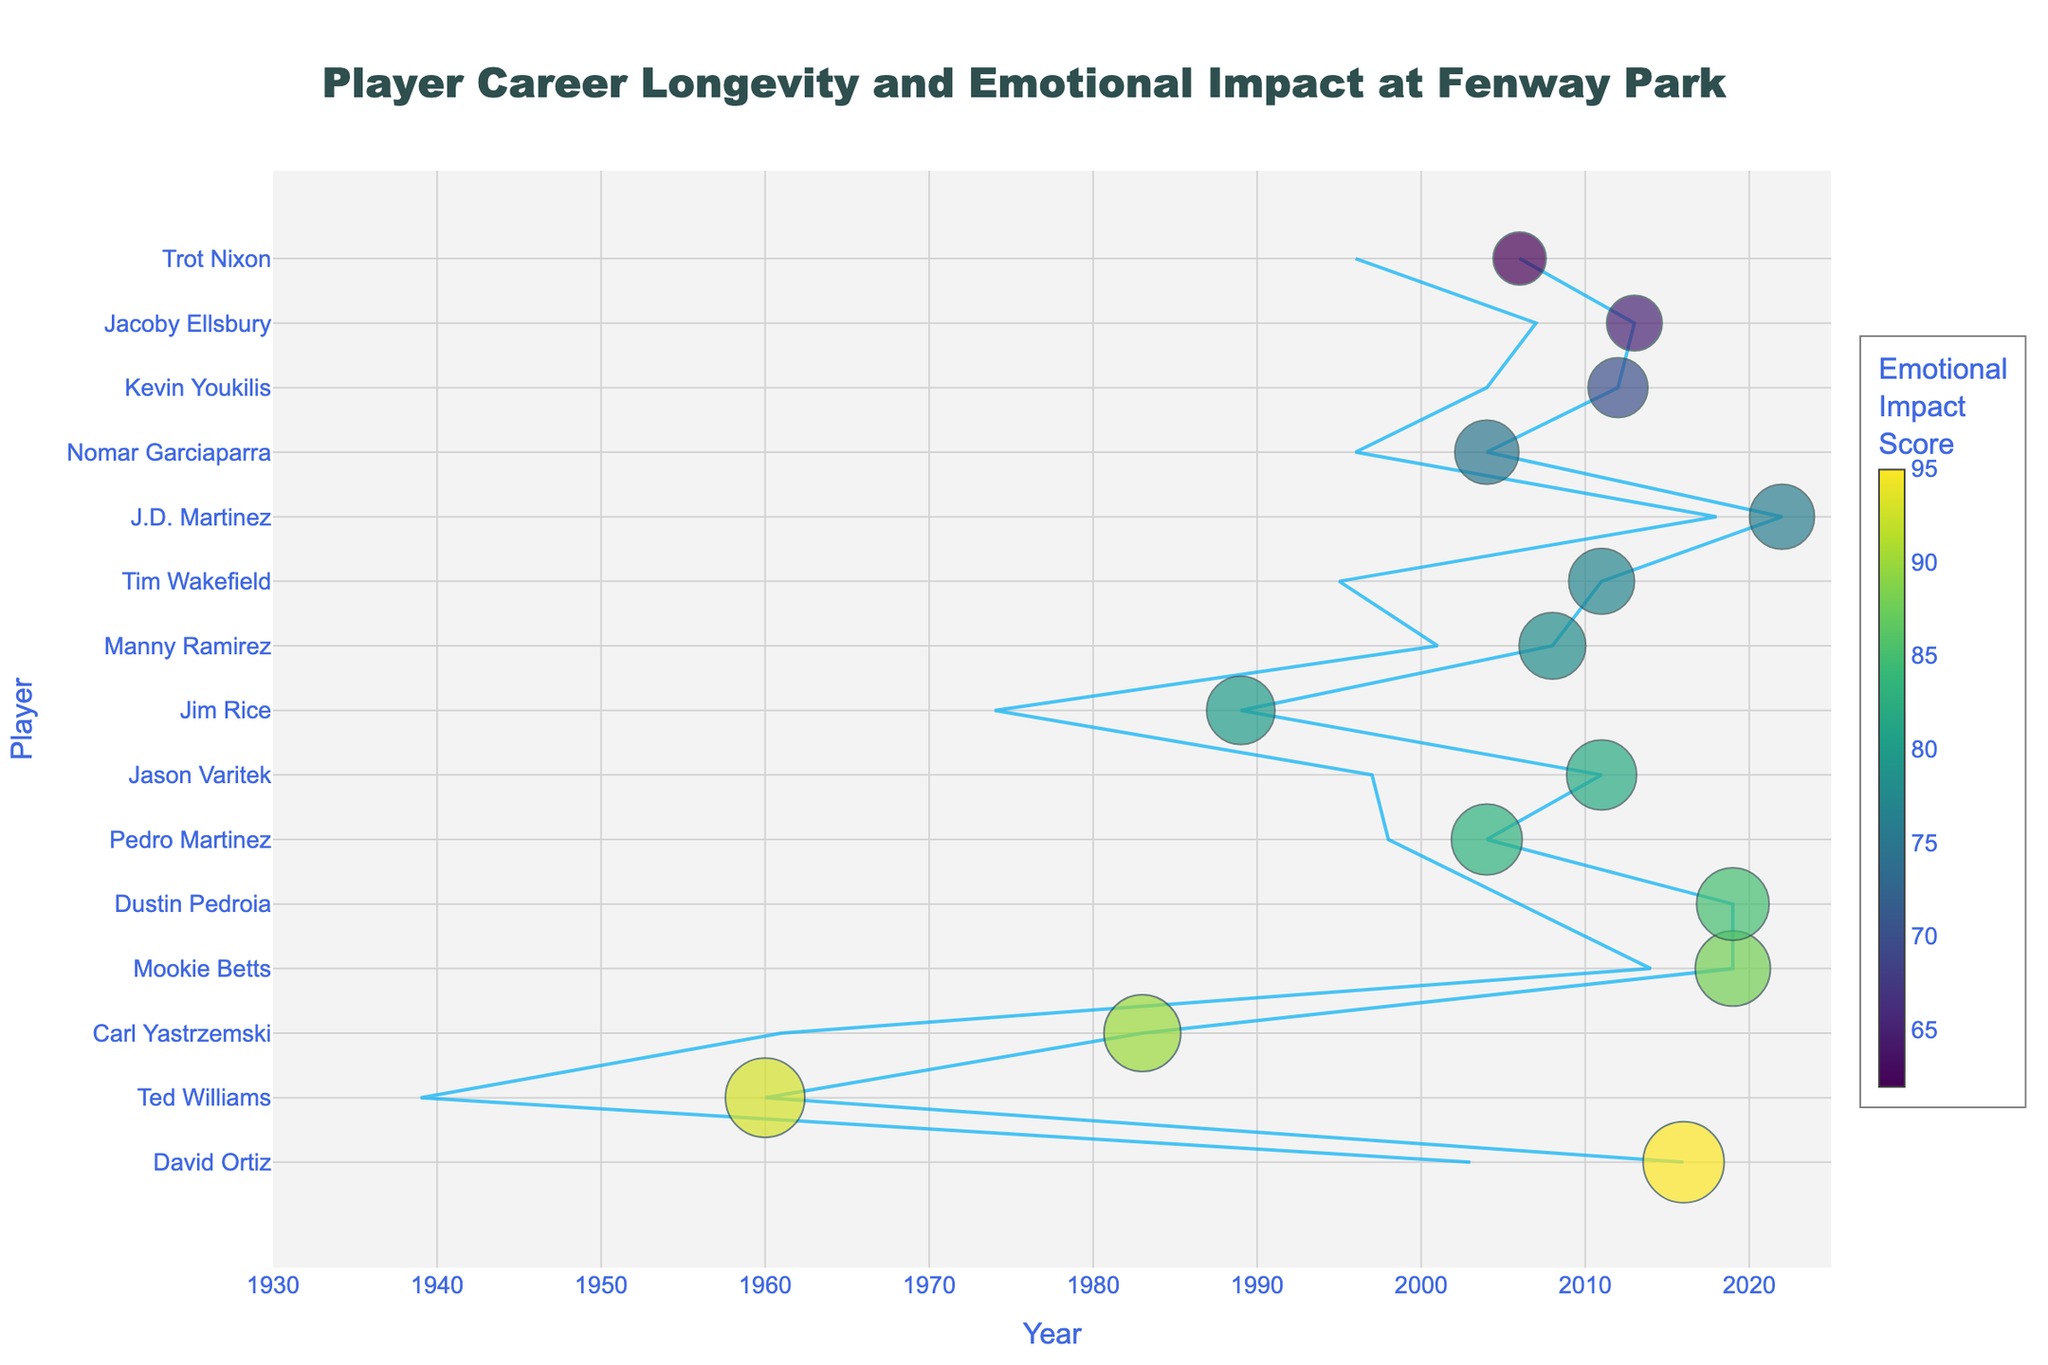What's the timeline covered in the plot? The x-axis starts from the year 1930 and extends to 2025, indicating that the timeline spans 95 years.
Answer: 1930-2025 Which player has the highest Emotional Impact Score? David Ortiz has the highest Emotional Impact Score, evident from his marker being the largest and the most intense in color. His score is 95.
Answer: David Ortiz How many players have an Emotional Impact Score of 80 or higher? To find this, count the number of players with markers that have a size and color intensity indicating scores of 80 or higher. There are 10 such players: David Ortiz, Ted Williams, Carl Yastrzemski, Mookie Betts, Dustin Pedroia, Jason Varitek, Pedro Martinez, Jim Rice, Manny Ramirez, and Tim Wakefield.
Answer: 10 Who played the longest span of years at Fenway Park? The player with the longest career span is Carl Yastrzemski, who played from 1961 to 1983, totaling 22 years.
Answer: Carl Yastrzemski Compare Ted Williams’ and Carl Yastrzemski’s Emotional Impact Scores. Who scored higher? Ted Williams has an Emotional Impact Score of 93, while Carl Yastrzemski has a score of 90. Therefore, Ted Williams scored higher.
Answer: Ted Williams What is the combined Emotional Impact Score of players who ended their careers before 2000? Summing up the Emotional Impact Scores of Ted Williams (93), Carl Yastrzemski (90), Jim Rice (80), and Nomar Garciaparra (75), we get 93 + 90 + 80 + 75 = 338.
Answer: 338 Which player had the shortest career span at Fenway Park? J.D. Martinez had the shortest career span from 2018 to 2022, spanning only 4 years.
Answer: J.D. Martinez How many years did David Ortiz play at Fenway Park? David Ortiz's career spanned from 2003 to 2016, totaling 13 years.
Answer: 13 years What is the average Emotional Impact Score for players who started their careers in the 1990s? First, identify the players: Nomar Garciaparra, Jason Varitek, Tim Wakefield, Pedro Martinez, and Trot Nixon. Their scores are 75, 82, 77, 83, and 62. The average is calculated as (75 + 82 + 77 + 83 + 62) / 5 = 75.8.
Answer: 75.8 